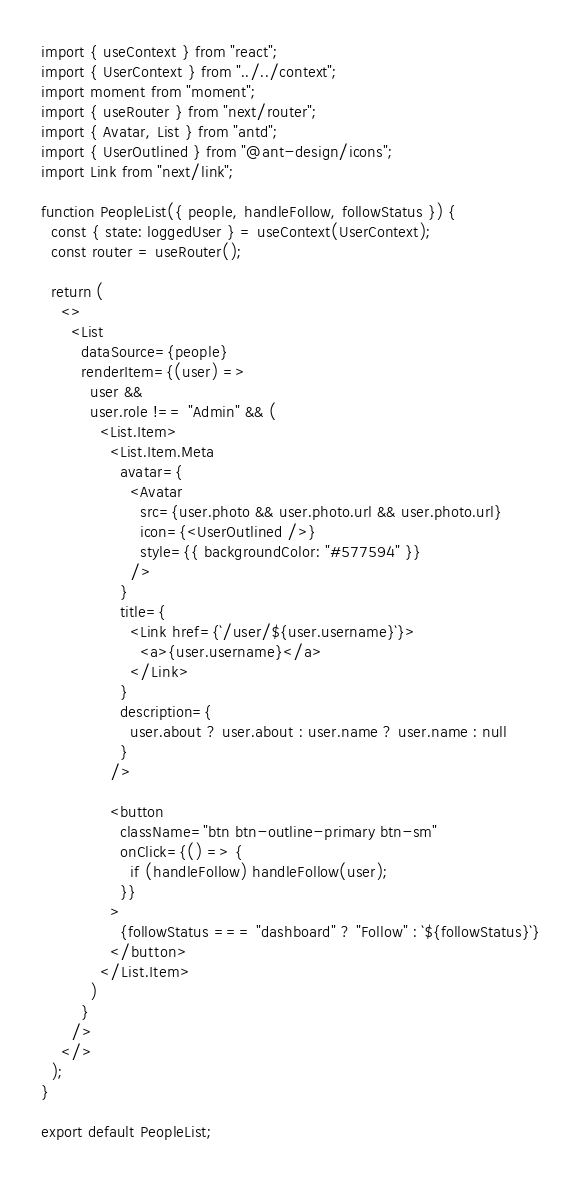<code> <loc_0><loc_0><loc_500><loc_500><_JavaScript_>import { useContext } from "react";
import { UserContext } from "../../context";
import moment from "moment";
import { useRouter } from "next/router";
import { Avatar, List } from "antd";
import { UserOutlined } from "@ant-design/icons";
import Link from "next/link";

function PeopleList({ people, handleFollow, followStatus }) {
  const { state: loggedUser } = useContext(UserContext);
  const router = useRouter();

  return (
    <>
      <List
        dataSource={people}
        renderItem={(user) =>
          user &&
          user.role !== "Admin" && (
            <List.Item>
              <List.Item.Meta
                avatar={
                  <Avatar
                    src={user.photo && user.photo.url && user.photo.url}
                    icon={<UserOutlined />}
                    style={{ backgroundColor: "#577594" }}
                  />
                }
                title={
                  <Link href={`/user/${user.username}`}>
                    <a>{user.username}</a>
                  </Link>
                }
                description={
                  user.about ? user.about : user.name ? user.name : null
                }
              />

              <button
                className="btn btn-outline-primary btn-sm"
                onClick={() => {
                  if (handleFollow) handleFollow(user);
                }}
              >
                {followStatus === "dashboard" ? "Follow" : `${followStatus}`}
              </button>
            </List.Item>
          )
        }
      />
    </>
  );
}

export default PeopleList;
</code> 